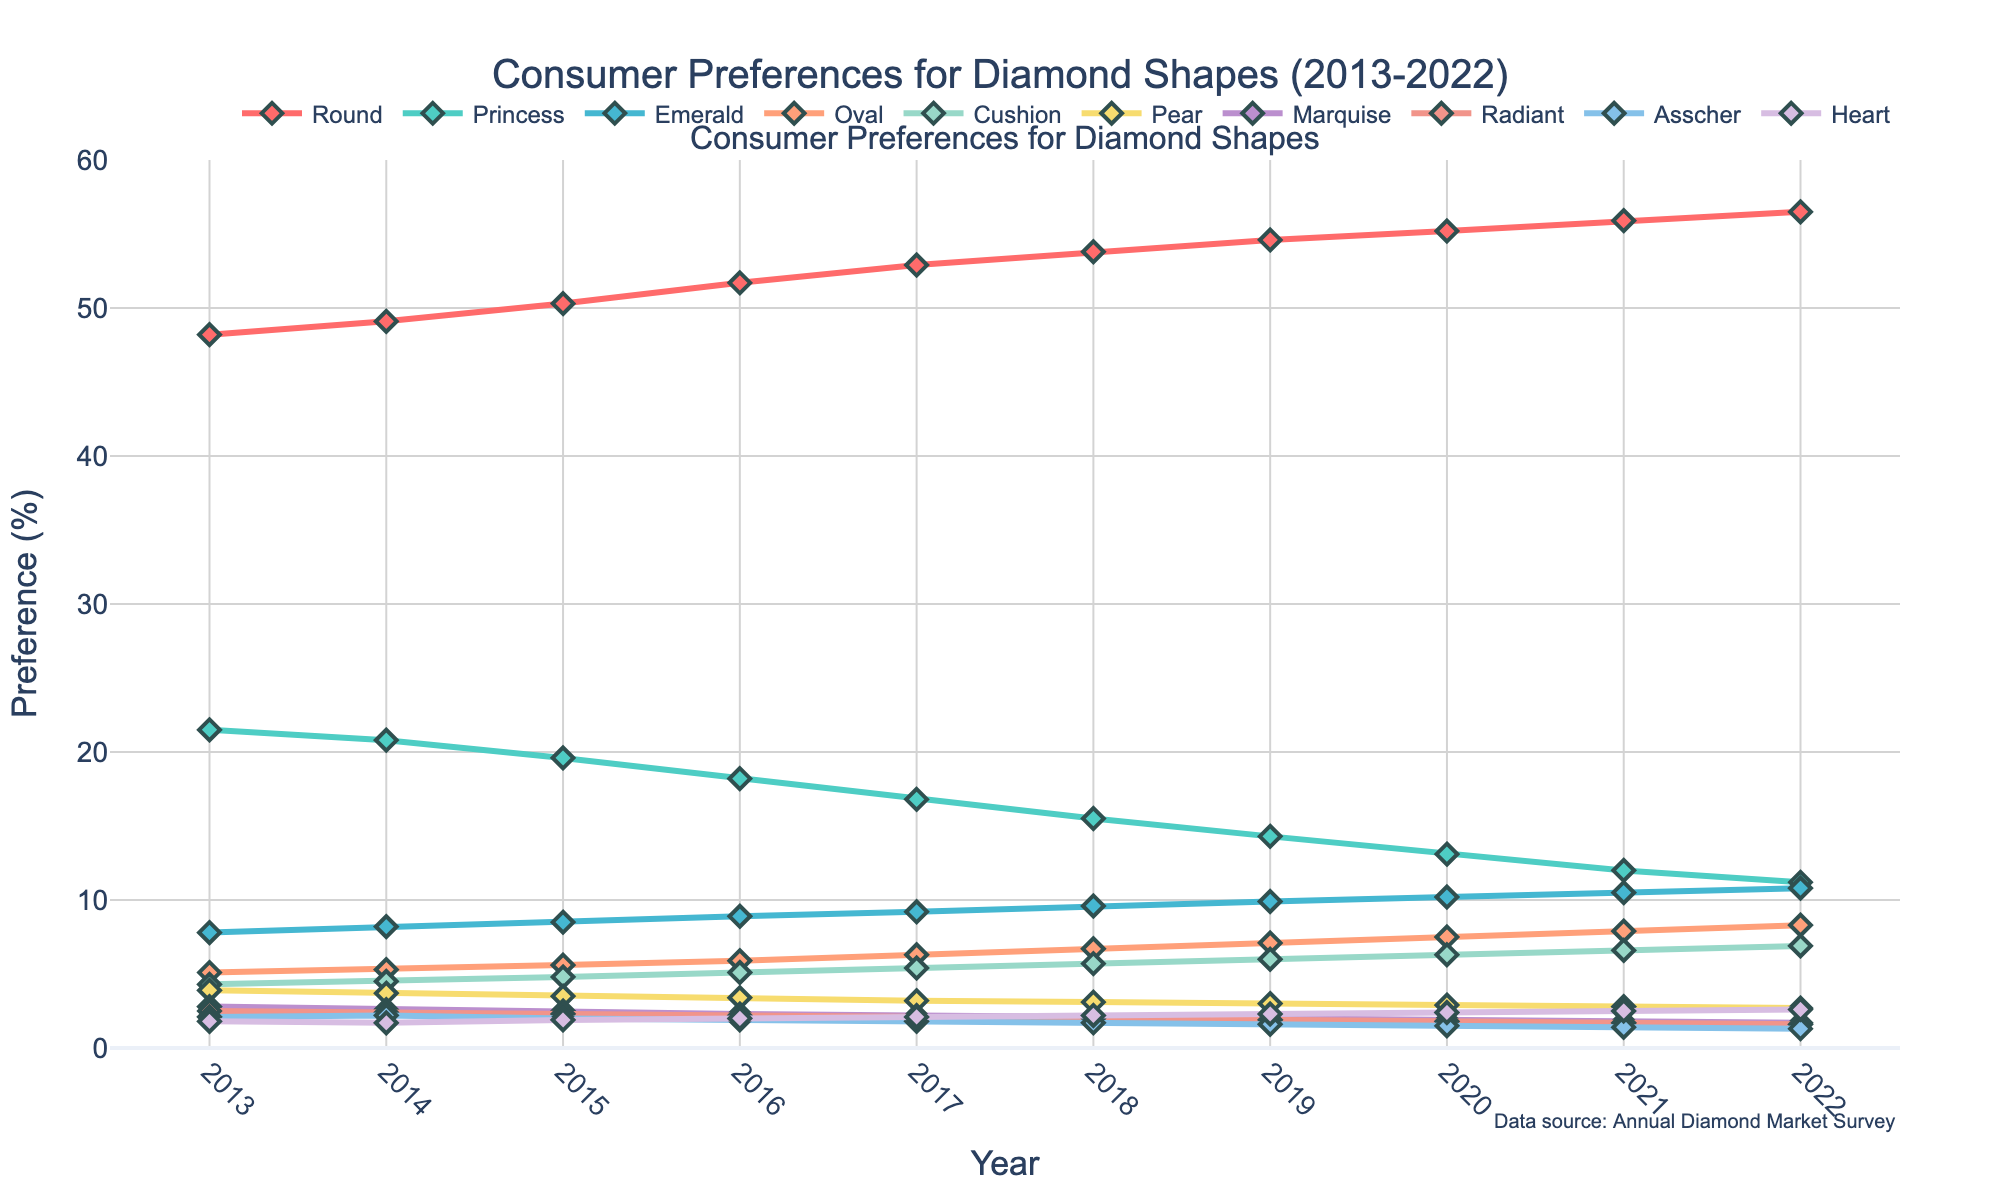what is the percentage increase in preference for the Oval shape from 2013 to 2022? The Oval shape preference starts at 5.1% in 2013 and increases to 8.3% in 2022. The increase can be calculated as follows: (8.3 - 5.1) / 5.1 * 100 = 62.7%
Answer: 62.7% which diamond shape had the largest decrease in preference over the decade? The Princess shape preference decreases from 21.5% in 2013 to 11.2% in 2022. The difference is 21.5 - 11.2 = 10.3%. This is the largest decrease among all the shapes.
Answer: Princess which two shapes had a similar preference percentage in 2018? In 2018, the percentages for Radiant and Asscher shapes are close, with Radiant at 2.0% and Asscher at 1.7%.
Answer: Radiant and Asscher what is the difference in preference between the most and least preferred diamond shapes in 2020? In 2020, Round is the most preferred at 55.2% and Marquise is the least preferred at 1.9%. The difference is 55.2 - 1.9 = 53.3%.
Answer: 53.3% what is the average preference for the Heart shape from 2013 to 2022? The preference percentages for Heart shape are: 1.8, 1.7, 1.9, 2.0, 2.1, 2.2, 2.3, 2.4, 2.5, 2.6. The sum is 21.5. The average is 21.5/10 = 2.15.
Answer: 2.15% which shape showed the most steady increase over the decade? The Round shape has shown a consistent increase every year from 48.2% in 2013 to 56.5% in 2022.
Answer: Round in what year did the preference for Emerald surpass 10%? The preference for Emerald surpassed 10% in the year 2020 when it reached 10.2%.
Answer: 2020 